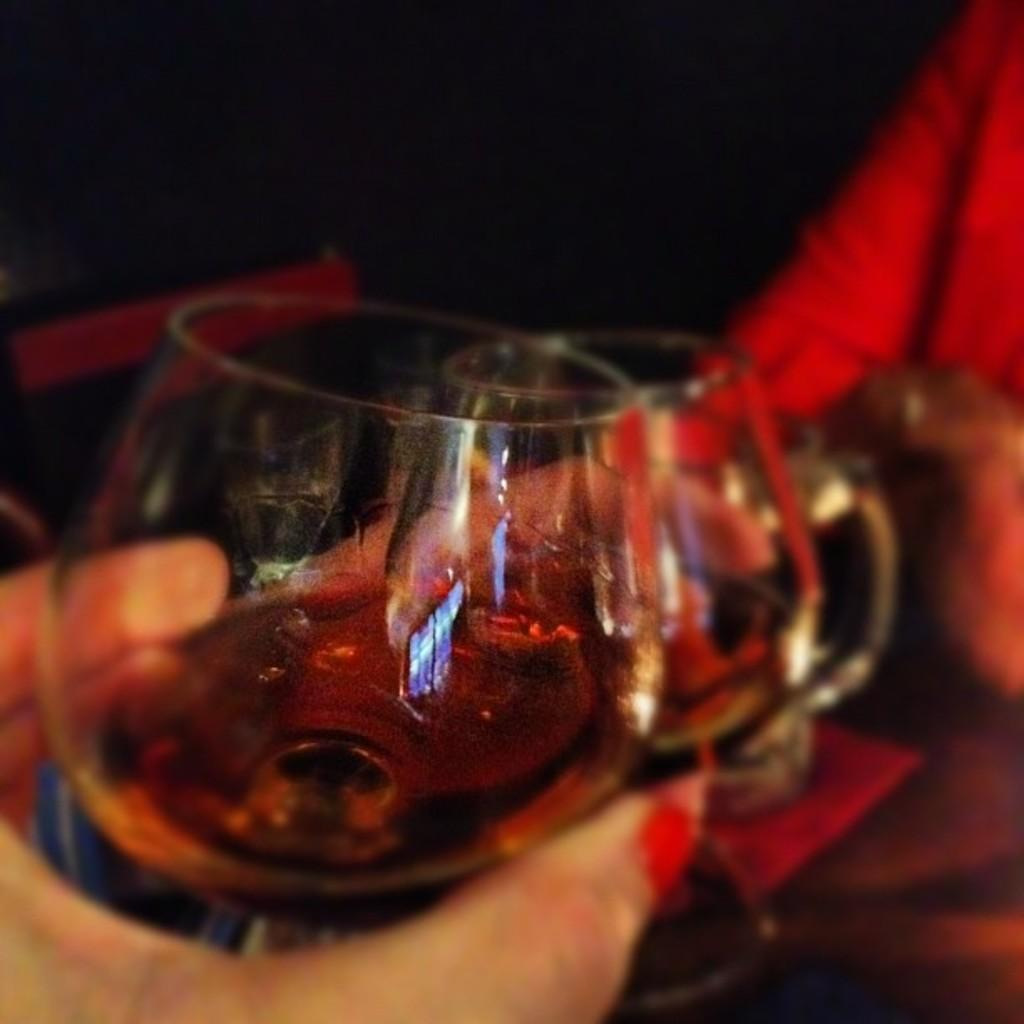How many people are in the image? There are two persons in the image. What are the persons holding in their hands? The persons are holding glasses of wine. Can you describe the background of the image? The background of the image is blurry. What instrument is the beginner playing in the image? There is no instrument or beginner present in the image. 